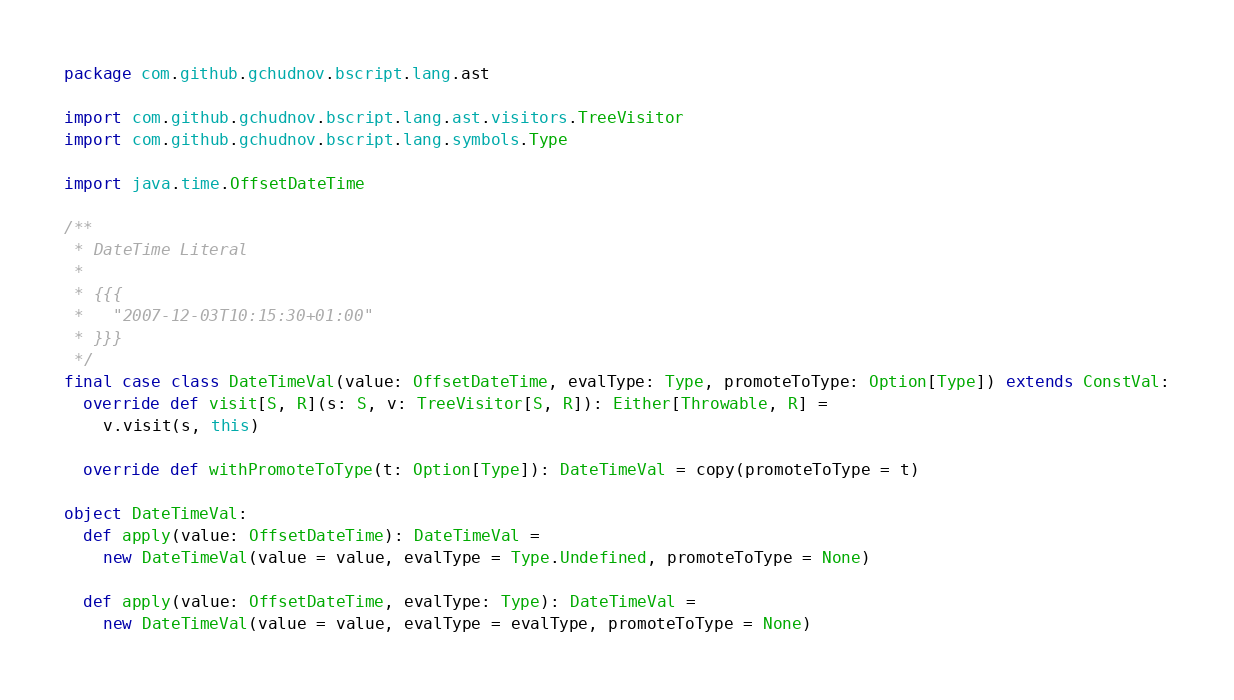Convert code to text. <code><loc_0><loc_0><loc_500><loc_500><_Scala_>package com.github.gchudnov.bscript.lang.ast

import com.github.gchudnov.bscript.lang.ast.visitors.TreeVisitor
import com.github.gchudnov.bscript.lang.symbols.Type

import java.time.OffsetDateTime

/**
 * DateTime Literal
 *
 * {{{
 *   "2007-12-03T10:15:30+01:00"
 * }}}
 */
final case class DateTimeVal(value: OffsetDateTime, evalType: Type, promoteToType: Option[Type]) extends ConstVal:
  override def visit[S, R](s: S, v: TreeVisitor[S, R]): Either[Throwable, R] =
    v.visit(s, this)

  override def withPromoteToType(t: Option[Type]): DateTimeVal = copy(promoteToType = t)

object DateTimeVal:
  def apply(value: OffsetDateTime): DateTimeVal =
    new DateTimeVal(value = value, evalType = Type.Undefined, promoteToType = None)

  def apply(value: OffsetDateTime, evalType: Type): DateTimeVal =
    new DateTimeVal(value = value, evalType = evalType, promoteToType = None)
</code> 